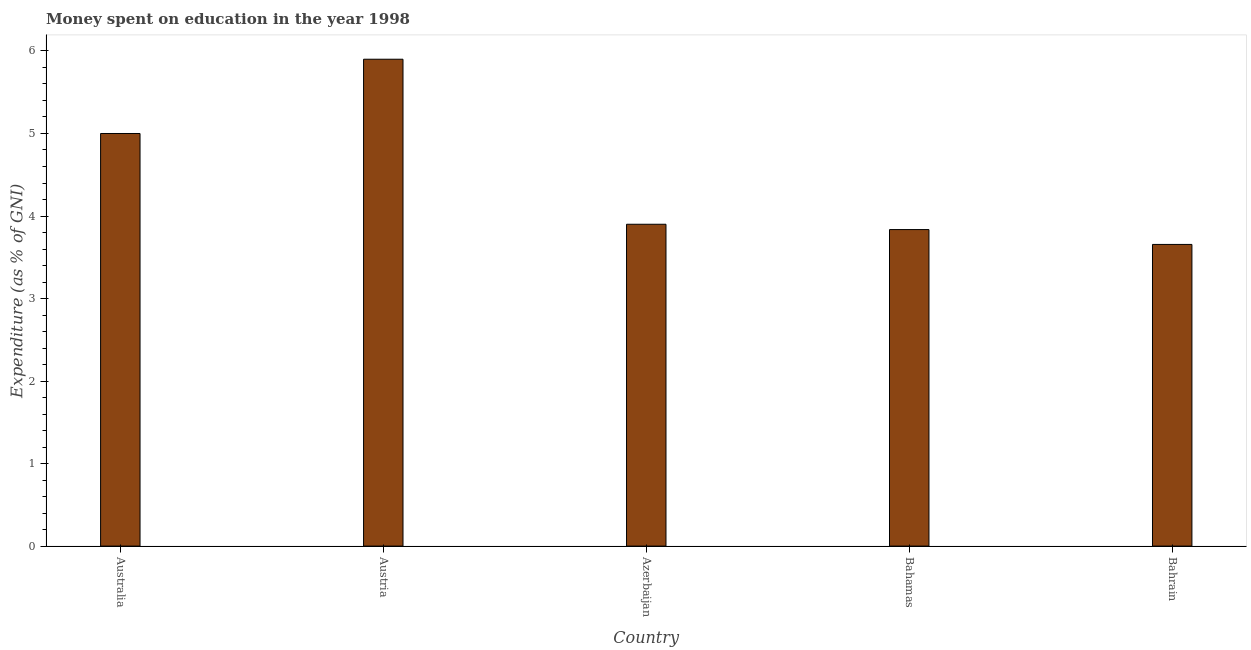Does the graph contain any zero values?
Your answer should be very brief. No. What is the title of the graph?
Ensure brevity in your answer.  Money spent on education in the year 1998. What is the label or title of the Y-axis?
Keep it short and to the point. Expenditure (as % of GNI). Across all countries, what is the minimum expenditure on education?
Provide a short and direct response. 3.66. In which country was the expenditure on education maximum?
Keep it short and to the point. Austria. In which country was the expenditure on education minimum?
Provide a succinct answer. Bahrain. What is the sum of the expenditure on education?
Your response must be concise. 22.29. What is the difference between the expenditure on education in Azerbaijan and Bahamas?
Keep it short and to the point. 0.06. What is the average expenditure on education per country?
Make the answer very short. 4.46. What is the median expenditure on education?
Your answer should be very brief. 3.9. In how many countries, is the expenditure on education greater than 4.4 %?
Provide a succinct answer. 2. What is the ratio of the expenditure on education in Bahamas to that in Bahrain?
Keep it short and to the point. 1.05. Is the expenditure on education in Australia less than that in Azerbaijan?
Ensure brevity in your answer.  No. Is the difference between the expenditure on education in Austria and Bahrain greater than the difference between any two countries?
Provide a short and direct response. Yes. What is the difference between the highest and the second highest expenditure on education?
Give a very brief answer. 0.9. Is the sum of the expenditure on education in Azerbaijan and Bahrain greater than the maximum expenditure on education across all countries?
Keep it short and to the point. Yes. What is the difference between the highest and the lowest expenditure on education?
Keep it short and to the point. 2.24. How many bars are there?
Offer a very short reply. 5. Are all the bars in the graph horizontal?
Provide a short and direct response. No. What is the difference between two consecutive major ticks on the Y-axis?
Ensure brevity in your answer.  1. Are the values on the major ticks of Y-axis written in scientific E-notation?
Your answer should be very brief. No. What is the Expenditure (as % of GNI) of Australia?
Offer a very short reply. 5. What is the Expenditure (as % of GNI) of Austria?
Give a very brief answer. 5.9. What is the Expenditure (as % of GNI) of Azerbaijan?
Offer a terse response. 3.9. What is the Expenditure (as % of GNI) of Bahamas?
Offer a terse response. 3.84. What is the Expenditure (as % of GNI) of Bahrain?
Offer a terse response. 3.66. What is the difference between the Expenditure (as % of GNI) in Australia and Austria?
Provide a short and direct response. -0.9. What is the difference between the Expenditure (as % of GNI) in Australia and Azerbaijan?
Offer a terse response. 1.1. What is the difference between the Expenditure (as % of GNI) in Australia and Bahamas?
Provide a short and direct response. 1.16. What is the difference between the Expenditure (as % of GNI) in Australia and Bahrain?
Your answer should be compact. 1.34. What is the difference between the Expenditure (as % of GNI) in Austria and Azerbaijan?
Give a very brief answer. 2. What is the difference between the Expenditure (as % of GNI) in Austria and Bahamas?
Your answer should be very brief. 2.06. What is the difference between the Expenditure (as % of GNI) in Austria and Bahrain?
Provide a succinct answer. 2.24. What is the difference between the Expenditure (as % of GNI) in Azerbaijan and Bahamas?
Your answer should be very brief. 0.06. What is the difference between the Expenditure (as % of GNI) in Azerbaijan and Bahrain?
Your response must be concise. 0.24. What is the difference between the Expenditure (as % of GNI) in Bahamas and Bahrain?
Keep it short and to the point. 0.18. What is the ratio of the Expenditure (as % of GNI) in Australia to that in Austria?
Offer a terse response. 0.85. What is the ratio of the Expenditure (as % of GNI) in Australia to that in Azerbaijan?
Ensure brevity in your answer.  1.28. What is the ratio of the Expenditure (as % of GNI) in Australia to that in Bahamas?
Keep it short and to the point. 1.3. What is the ratio of the Expenditure (as % of GNI) in Australia to that in Bahrain?
Offer a terse response. 1.37. What is the ratio of the Expenditure (as % of GNI) in Austria to that in Azerbaijan?
Offer a very short reply. 1.51. What is the ratio of the Expenditure (as % of GNI) in Austria to that in Bahamas?
Make the answer very short. 1.54. What is the ratio of the Expenditure (as % of GNI) in Austria to that in Bahrain?
Keep it short and to the point. 1.61. What is the ratio of the Expenditure (as % of GNI) in Azerbaijan to that in Bahrain?
Your answer should be very brief. 1.07. What is the ratio of the Expenditure (as % of GNI) in Bahamas to that in Bahrain?
Your answer should be compact. 1.05. 